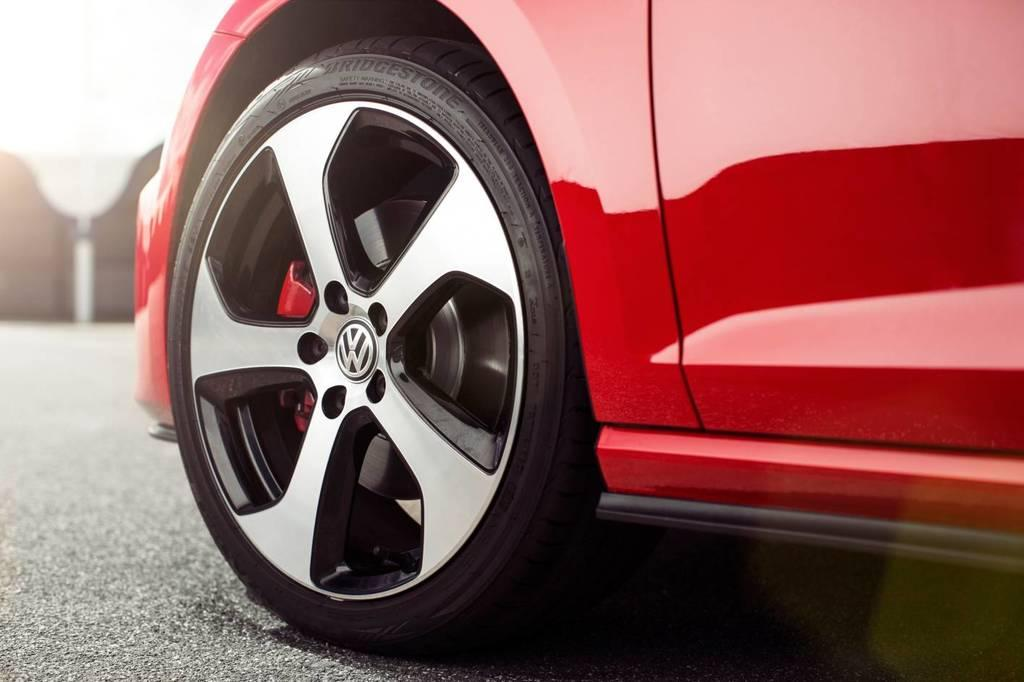What is the main subject of the image? The main subject of the image is a wheel of a vehicle. Where is the wheel located in the image? The wheel is on the road. Can you describe the background of the image? The background of the image is blurry. What type of toy can be seen on the sofa in the image? There is no sofa or toy present in the image; it only features a wheel of a vehicle on the road with a blurry background. 